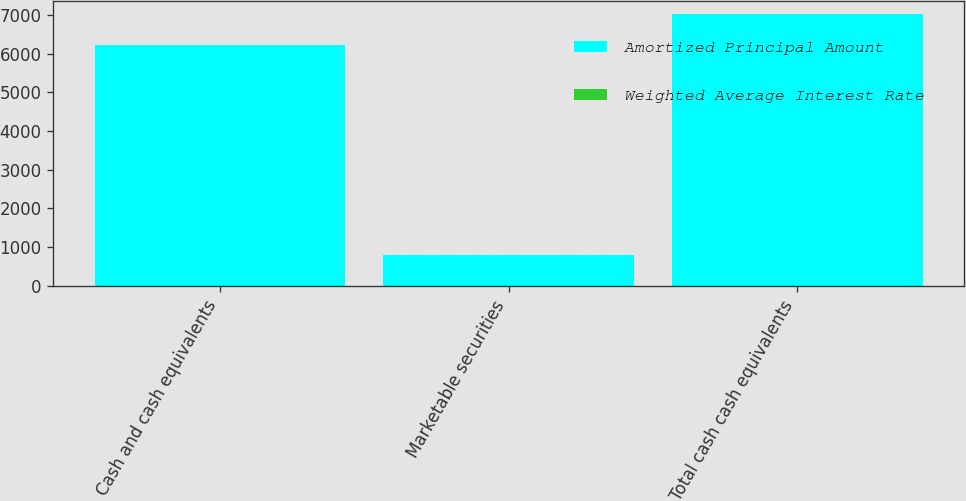Convert chart. <chart><loc_0><loc_0><loc_500><loc_500><stacked_bar_chart><ecel><fcel>Cash and cash equivalents<fcel>Marketable securities<fcel>Total cash cash equivalents<nl><fcel>Amortized Principal Amount<fcel>6218<fcel>802<fcel>7020<nl><fcel>Weighted Average Interest Rate<fcel>4.08<fcel>2.89<fcel>3.95<nl></chart> 